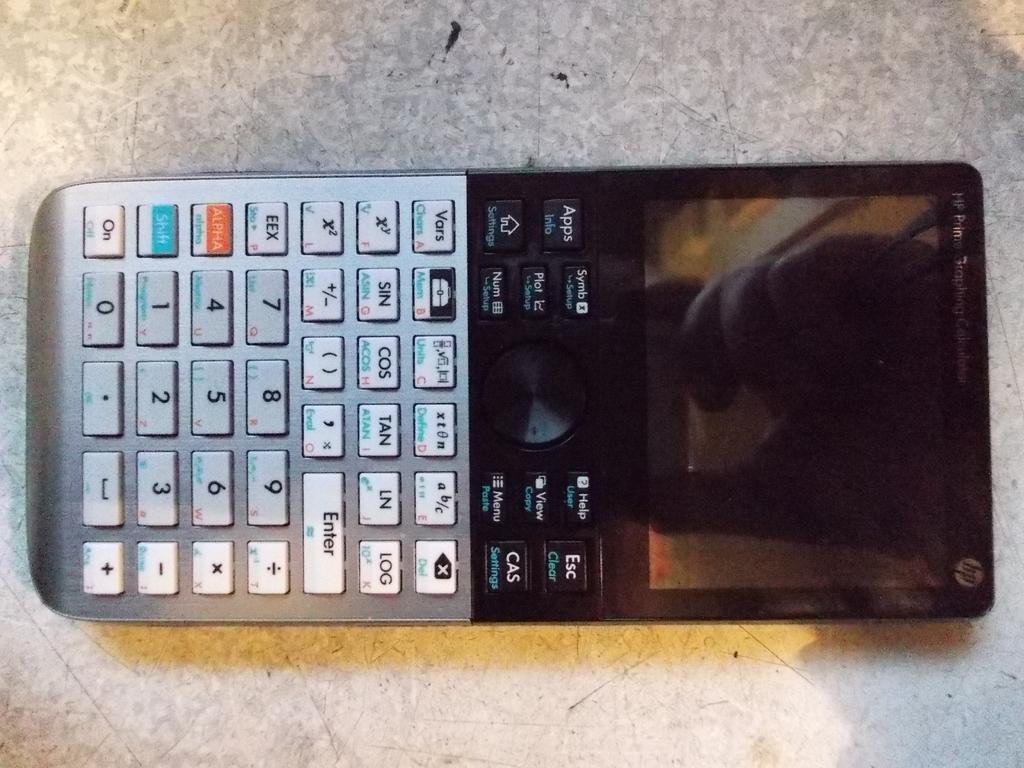<image>
Summarize the visual content of the image. A electronic device with a screen and numbers and other tabs from HP. 